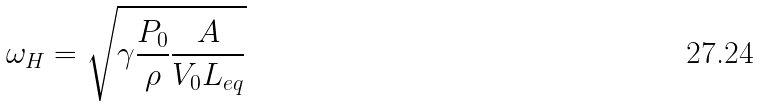<formula> <loc_0><loc_0><loc_500><loc_500>\omega _ { H } = \sqrt { \gamma \frac { P _ { 0 } } { \rho } \frac { A } { V _ { 0 } L _ { e q } } }</formula> 